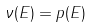<formula> <loc_0><loc_0><loc_500><loc_500>\nu ( E ) = p ( E )</formula> 